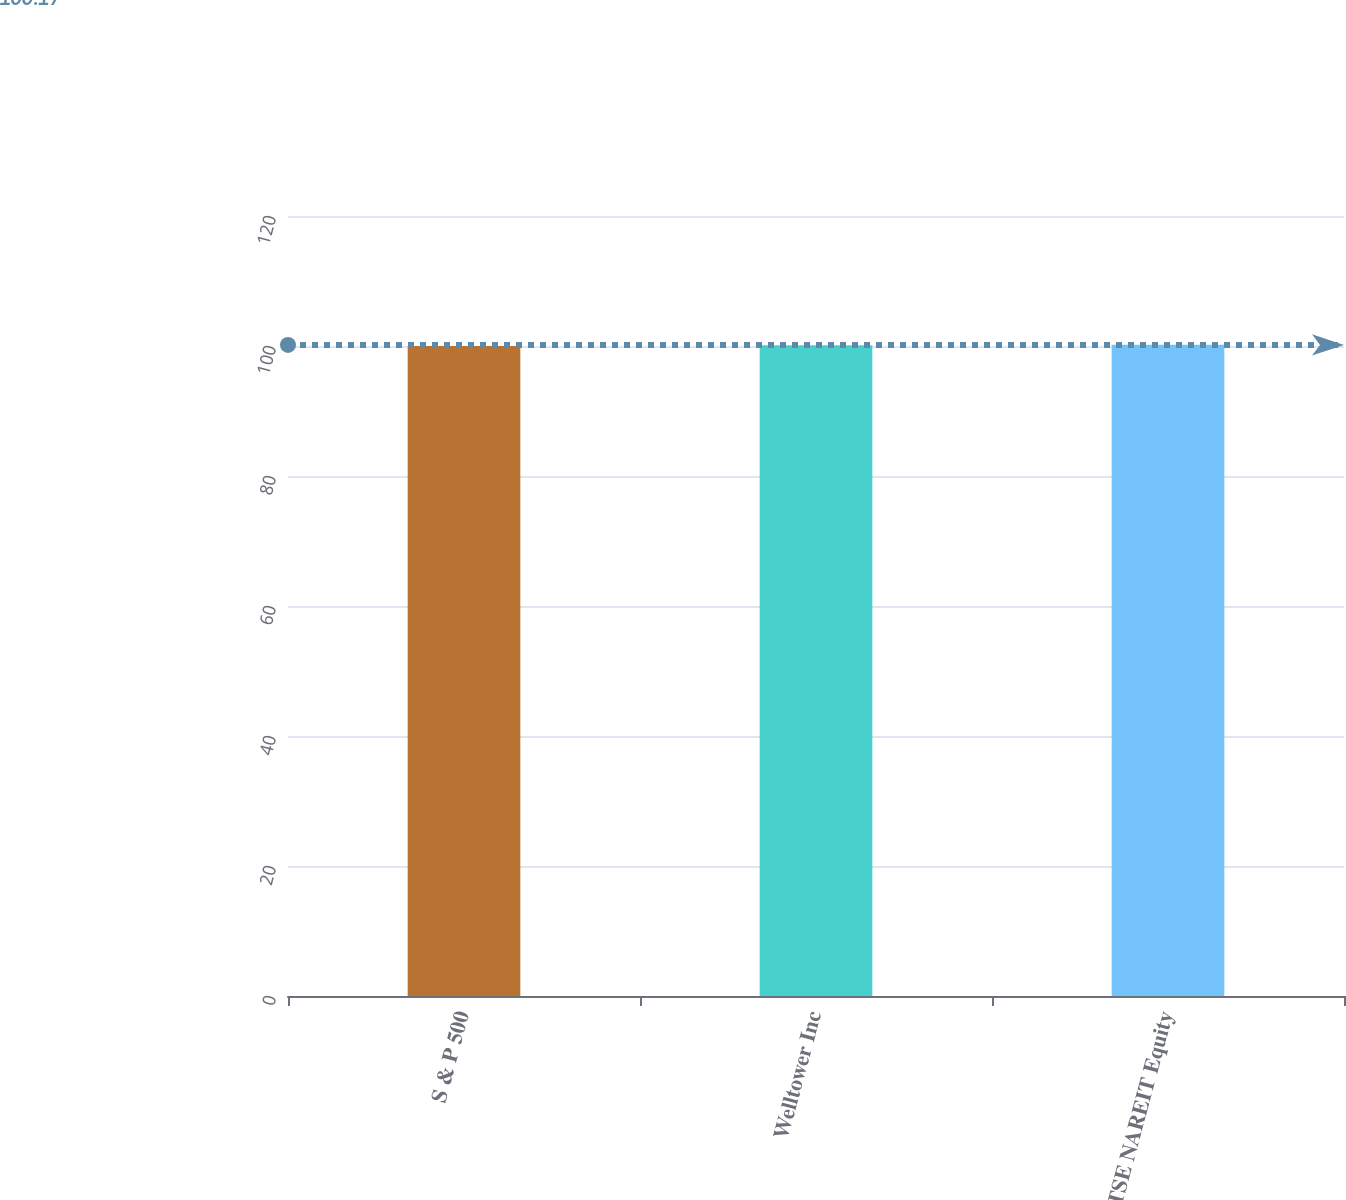Convert chart to OTSL. <chart><loc_0><loc_0><loc_500><loc_500><bar_chart><fcel>S & P 500<fcel>Welltower Inc<fcel>FTSE NAREIT Equity<nl><fcel>100<fcel>100.1<fcel>100.2<nl></chart> 